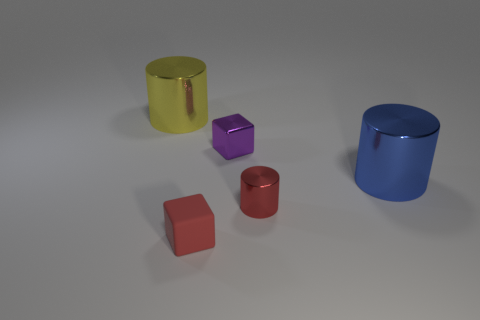Add 1 small shiny objects. How many objects exist? 6 Subtract all cubes. How many objects are left? 3 Subtract all yellow shiny things. Subtract all purple metallic things. How many objects are left? 3 Add 2 blue things. How many blue things are left? 3 Add 1 gray shiny balls. How many gray shiny balls exist? 1 Subtract 0 red spheres. How many objects are left? 5 